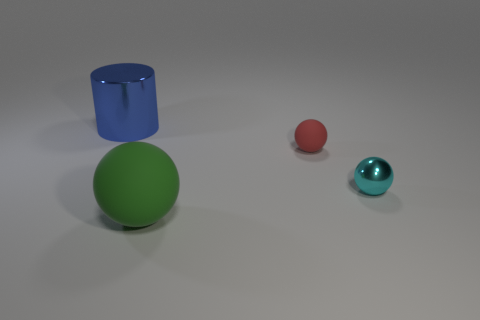What is the texture of the red object? The red object, which is a small sphere, appears to have a smooth texture with a slightly shiny surface, reflecting a bit of light and giving it a subtle luster. 